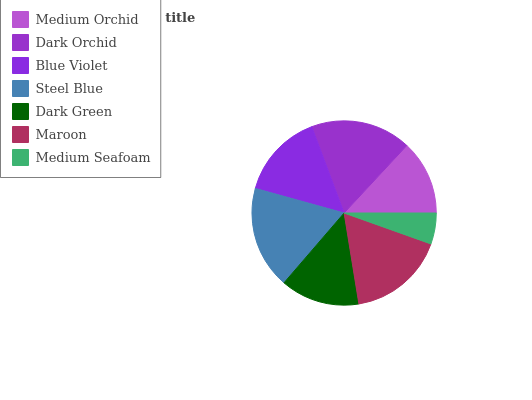Is Medium Seafoam the minimum?
Answer yes or no. Yes. Is Steel Blue the maximum?
Answer yes or no. Yes. Is Dark Orchid the minimum?
Answer yes or no. No. Is Dark Orchid the maximum?
Answer yes or no. No. Is Dark Orchid greater than Medium Orchid?
Answer yes or no. Yes. Is Medium Orchid less than Dark Orchid?
Answer yes or no. Yes. Is Medium Orchid greater than Dark Orchid?
Answer yes or no. No. Is Dark Orchid less than Medium Orchid?
Answer yes or no. No. Is Blue Violet the high median?
Answer yes or no. Yes. Is Blue Violet the low median?
Answer yes or no. Yes. Is Steel Blue the high median?
Answer yes or no. No. Is Steel Blue the low median?
Answer yes or no. No. 